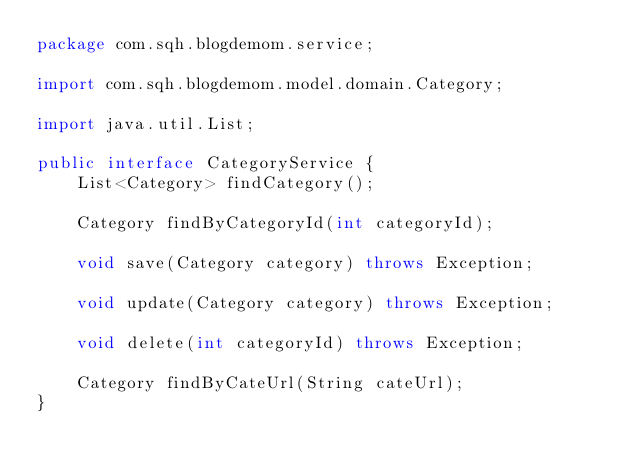<code> <loc_0><loc_0><loc_500><loc_500><_Java_>package com.sqh.blogdemom.service;

import com.sqh.blogdemom.model.domain.Category;

import java.util.List;

public interface CategoryService {
    List<Category> findCategory();

    Category findByCategoryId(int categoryId);

    void save(Category category) throws Exception;

    void update(Category category) throws Exception;

    void delete(int categoryId) throws Exception;

    Category findByCateUrl(String cateUrl);
}
</code> 